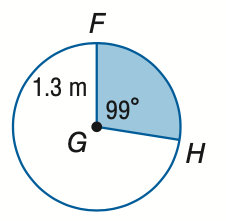Answer the mathemtical geometry problem and directly provide the correct option letter.
Question: Find the area of the shaded sector. Round to the nearest tenth.
Choices: A: 1.5 B: 2.2 C: 3.8 D: 5.3 A 